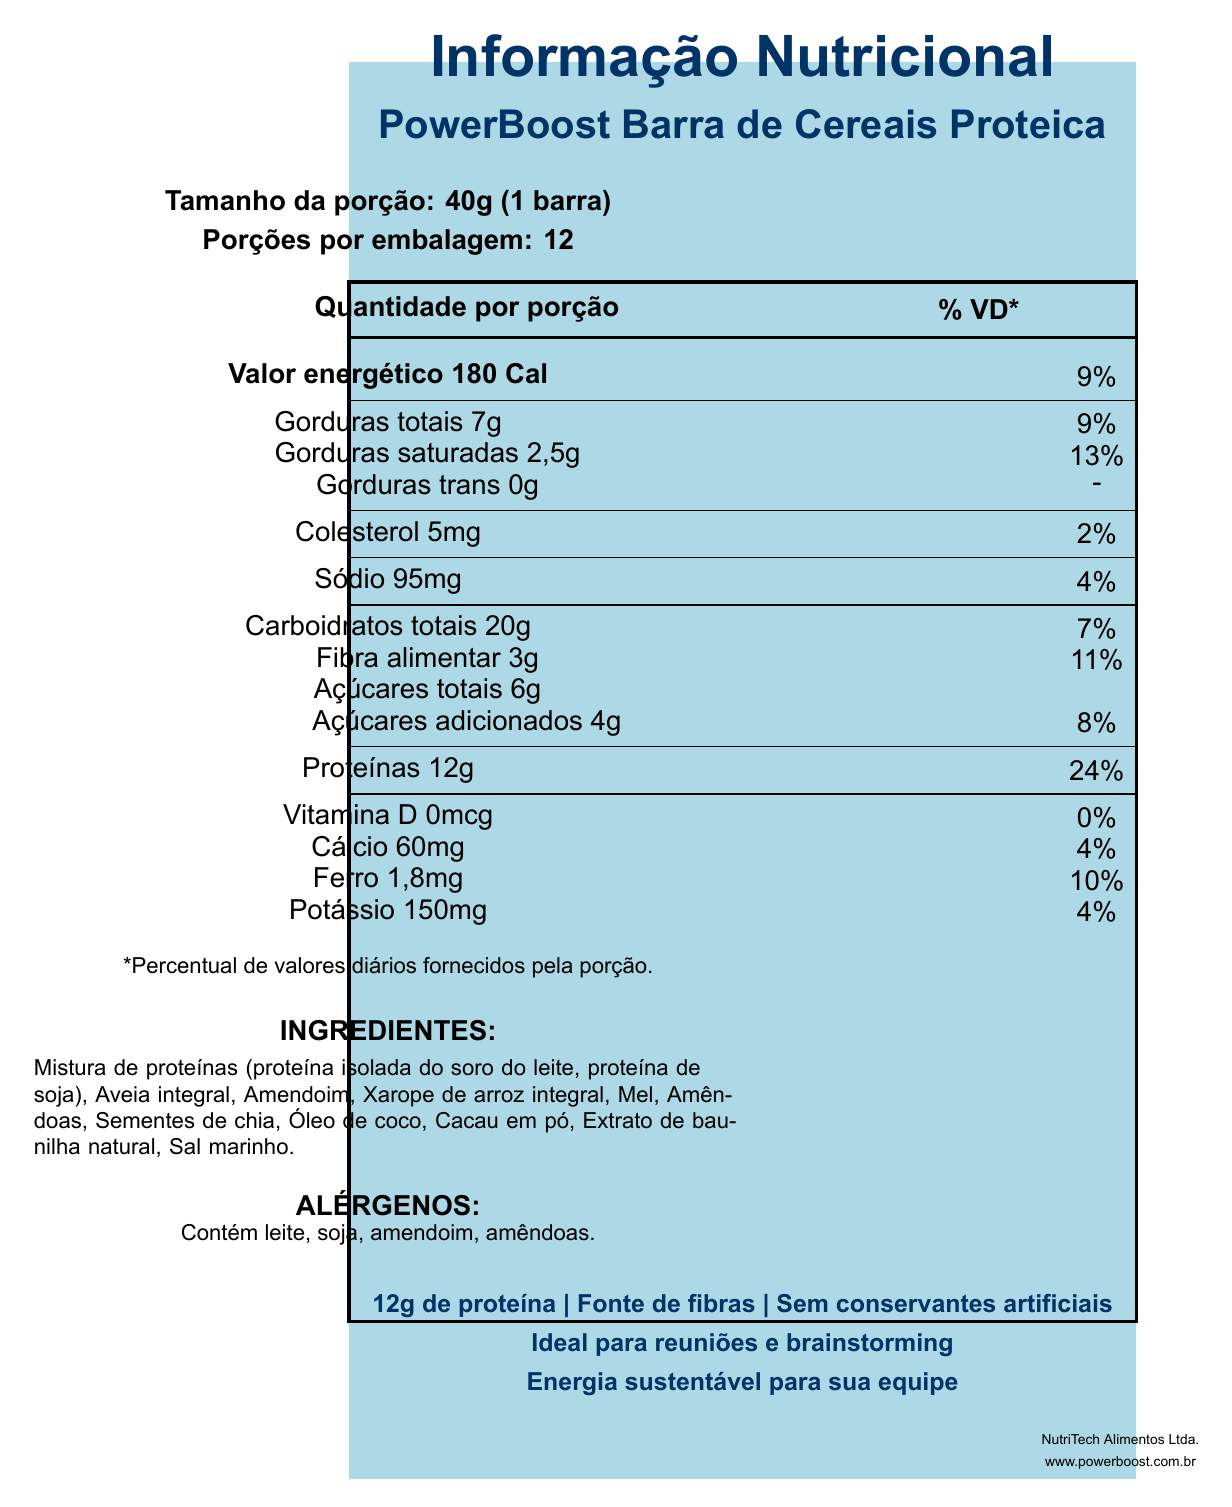What is the serving size of the PowerBoost Barra de Cereais Proteica? The document clearly states the serving size as "40g (1 barra)" in the section labeled "Tamanho da porção."
Answer: 40g (1 barra) How many servings are there per container? The document lists "Porções por embalagem: 12" directly under the serving size information.
Answer: 12 How many calories are in one serving of the bar? "Valor energético 180 Cal" is clearly displayed in the nutrition information section.
Answer: 180 What is the percent daily value of saturated fat in one serving? The document shows "Gorduras saturadas 2,5g" with a daily value of "13%."
Answer: 13% How much protein is in each bar? The amount of protein is listed as "Proteínas 12g" in the nutrition information section.
Answer: 12g Which of the following is not an allergen found in the bar? A. Milk B. Peanuts C. Egg The allergens listed are "Contém leite, soja, amendoim, amêndoas," and egg is not mentioned.
Answer: C What is the total amount of carbohydrates in one serving? A. 20g B. 7g C. 6g D. 12g The document states "Carboidratos totais 20g" as the total amount of carbohydrates per serving.
Answer: A Does the bar contain any added sugars? The document indicates "Açúcares adicionados 4g" as part of the sugar content.
Answer: Yes What is the main idea of the document? This summary captures all the key sections in the document, which include nutritional facts, ingredients, allergens, and other features.
Answer: The document provides detailed nutritional information about the PowerBoost Barra de Cereais Proteica, highlighting its serving size, calorie content, macronutrients, vitamins, minerals, ingredients, allergens, and marketing claims. Can we determine the price of the PowerBoost Barra de Cereais Proteica from this document? The document contains detailed nutritional information but does not mention the price.
Answer: No Who is the manufacturer of the bar? The manufacturer information is listed at the bottom of the document: "NutriTech Alimentos Ltda."
Answer: NutriTech Alimentos Ltda. What types of protein are included in the bar? The ingredients list in the document includes "Mistura de proteínas (proteína isolada do soro do leite, proteína de soja)."
Answer: Whey Protein Isolate and Soy Protein Does the product contain artificial preservatives? One of the marketing claims is "Sem conservantes artificiais," indicating there are no artificial preservatives.
Answer: No 